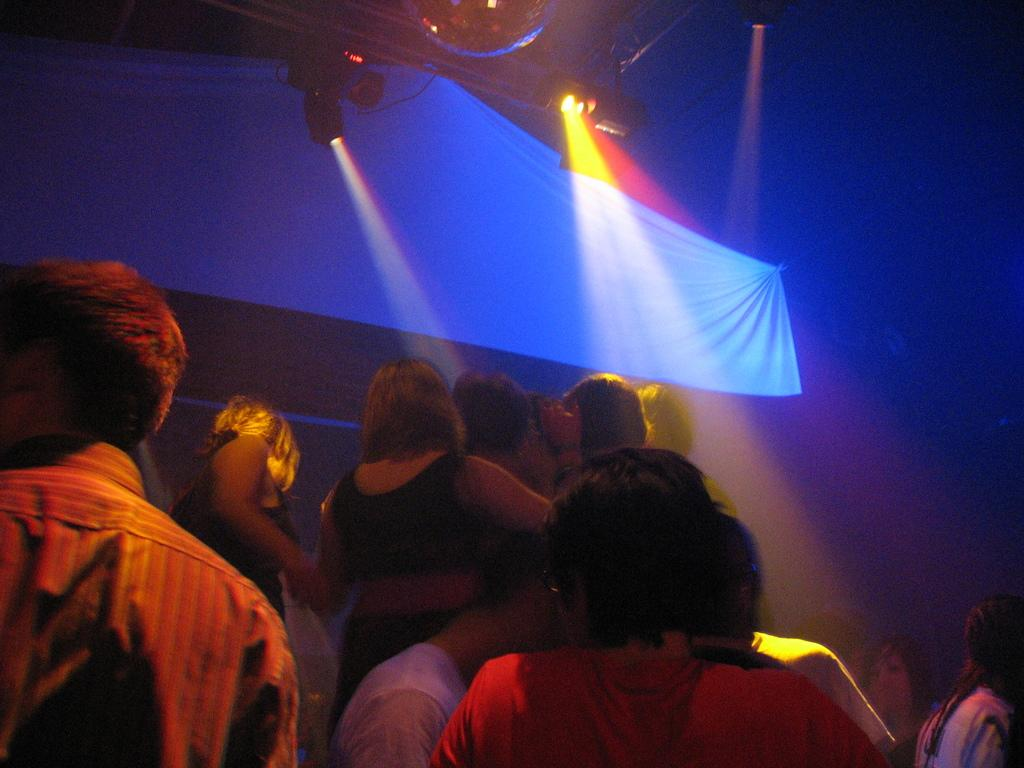Who or what is present in the image? There are people in the image. What can be observed about the people's clothing? The people are wearing different color dresses. What else can be seen in the image besides the people? There are lights visible in the image. What is the color of the cloth present in the image? There is a white color cloth in the image. How many knees are visible in the image? There is no specific mention of knees in the provided facts, so it is impossible to determine the number of knees visible in the image. 